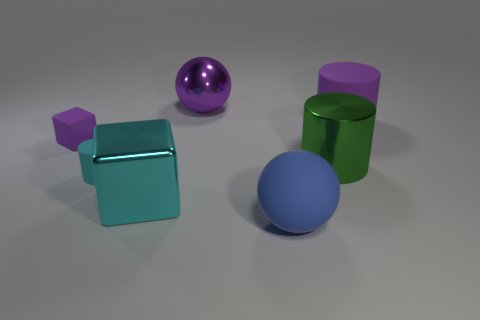What shape is the purple object that is made of the same material as the tiny purple cube?
Keep it short and to the point. Cylinder. Is there a small rubber sphere of the same color as the large rubber sphere?
Your response must be concise. No. What material is the large cyan block?
Your answer should be compact. Metal. How many things are either big purple things or yellow cylinders?
Offer a very short reply. 2. What size is the sphere that is behind the blue object?
Make the answer very short. Large. What number of other objects are there of the same material as the tiny purple block?
Keep it short and to the point. 3. Is there a blue rubber sphere in front of the small rubber thing that is in front of the big green metal object?
Make the answer very short. Yes. Is there anything else that is the same shape as the tiny cyan object?
Provide a succinct answer. Yes. There is another big matte object that is the same shape as the green object; what is its color?
Your response must be concise. Purple. What is the size of the purple matte cube?
Ensure brevity in your answer.  Small. 